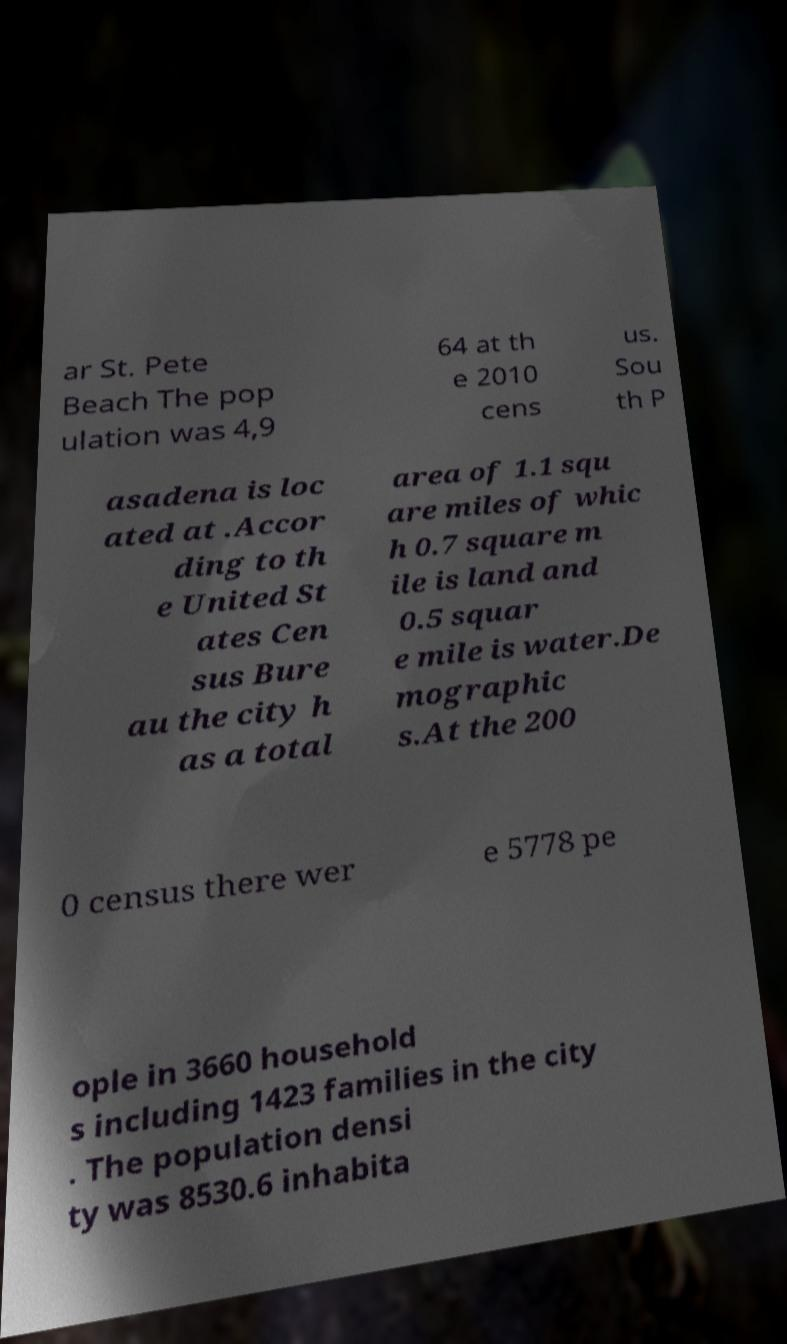Could you extract and type out the text from this image? ar St. Pete Beach The pop ulation was 4,9 64 at th e 2010 cens us. Sou th P asadena is loc ated at .Accor ding to th e United St ates Cen sus Bure au the city h as a total area of 1.1 squ are miles of whic h 0.7 square m ile is land and 0.5 squar e mile is water.De mographic s.At the 200 0 census there wer e 5778 pe ople in 3660 household s including 1423 families in the city . The population densi ty was 8530.6 inhabita 